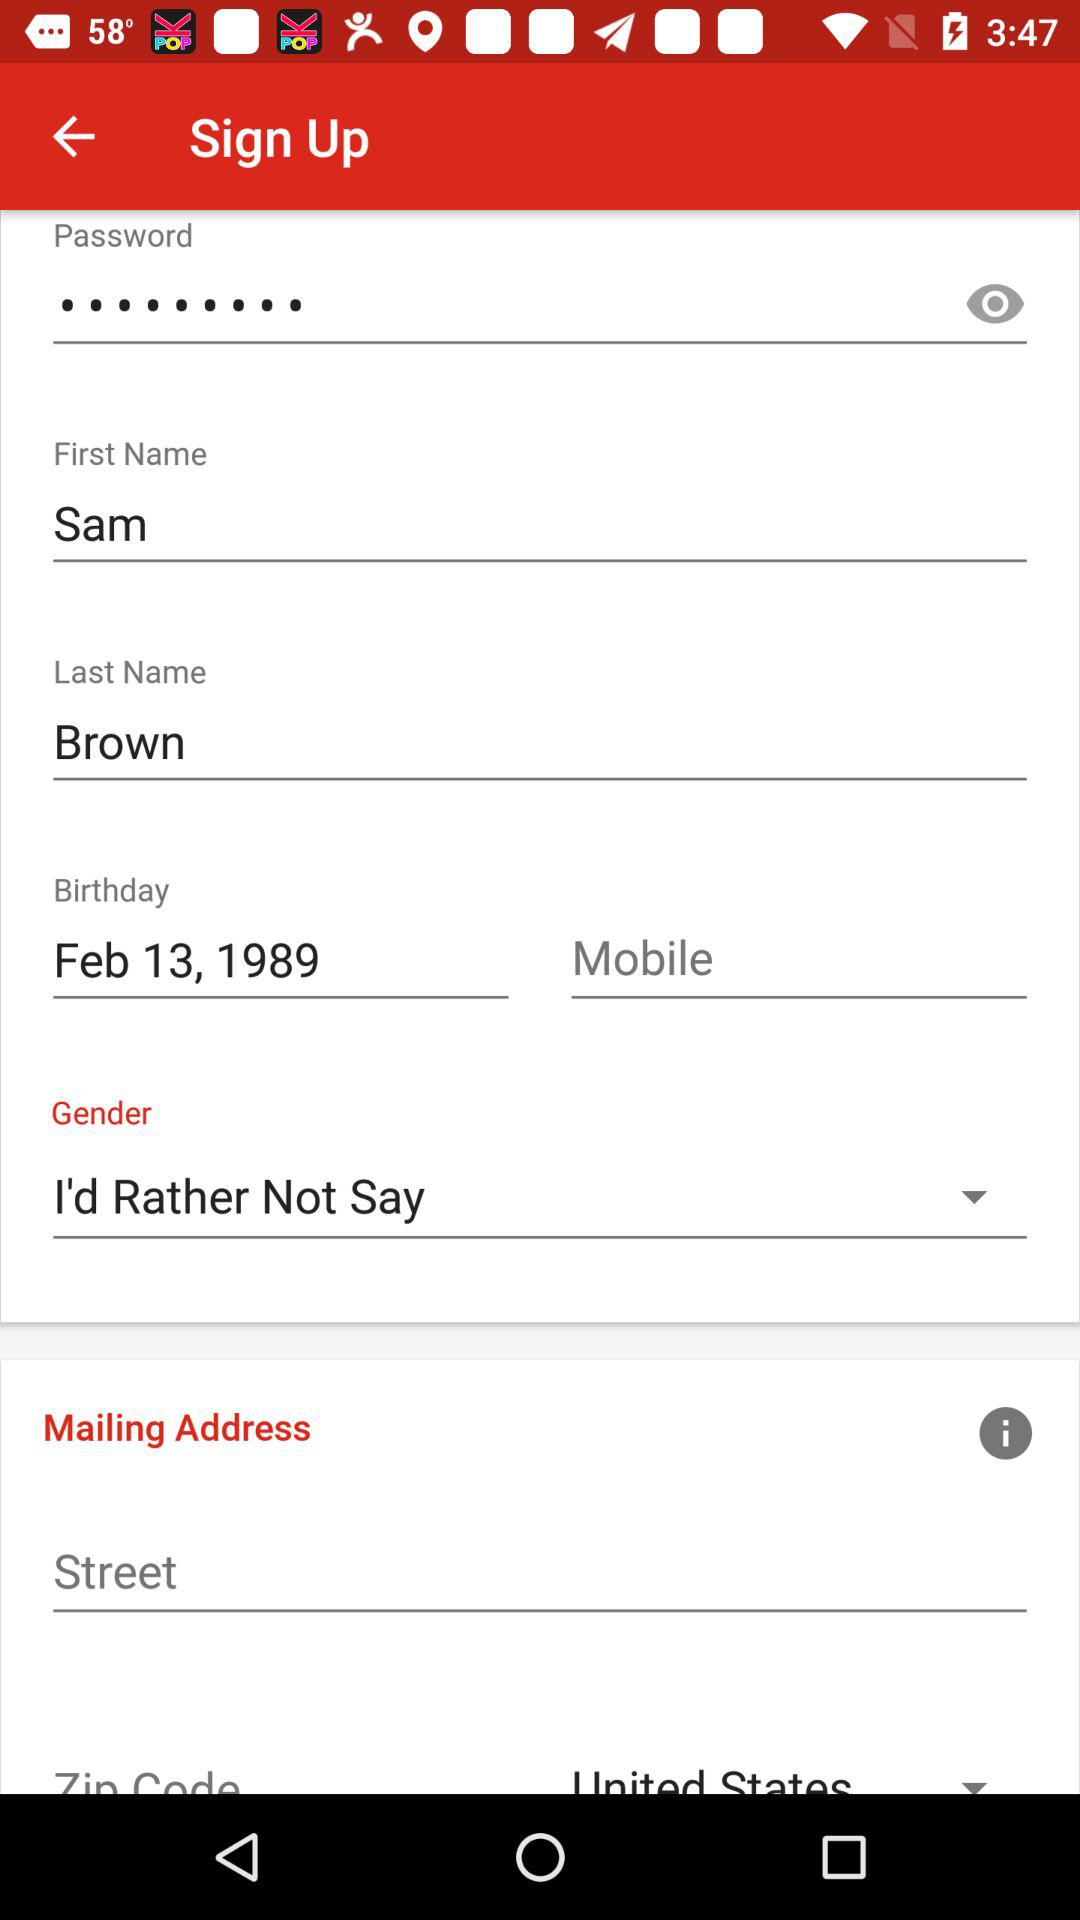What is the given first name? The given first name is Sam. 